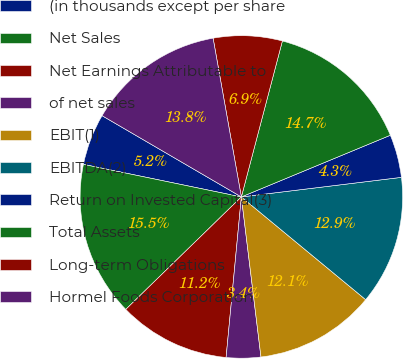Convert chart. <chart><loc_0><loc_0><loc_500><loc_500><pie_chart><fcel>(in thousands except per share<fcel>Net Sales<fcel>Net Earnings Attributable to<fcel>of net sales<fcel>EBIT(1)<fcel>EBITDA(2)<fcel>Return on Invested Capital(3)<fcel>Total Assets<fcel>Long-term Obligations<fcel>Hormel Foods Corporation<nl><fcel>5.17%<fcel>15.52%<fcel>11.21%<fcel>3.45%<fcel>12.07%<fcel>12.93%<fcel>4.31%<fcel>14.66%<fcel>6.9%<fcel>13.79%<nl></chart> 